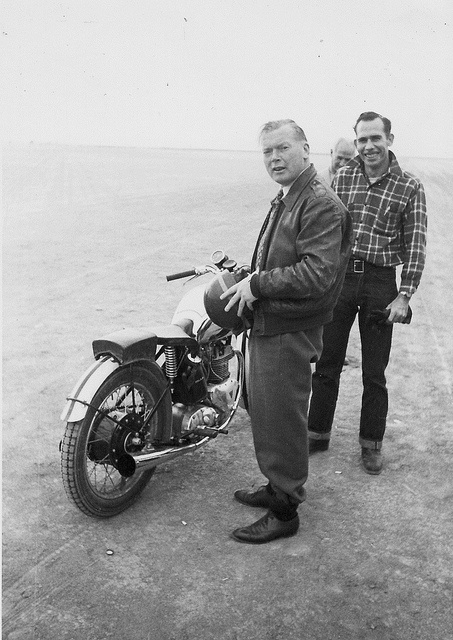Describe the objects in this image and their specific colors. I can see people in lightgray, black, gray, and darkgray tones, motorcycle in lightgray, black, gray, and darkgray tones, people in lightgray, black, gray, and darkgray tones, and people in lightgray, darkgray, gray, and black tones in this image. 